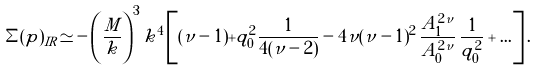<formula> <loc_0><loc_0><loc_500><loc_500>\Sigma ( p ) _ { I R } \simeq - \left ( \frac { M } { k } \right ) ^ { 3 } k ^ { 4 } \left [ ( \nu - 1 ) + q _ { 0 } ^ { 2 } \frac { 1 } { 4 ( \nu - 2 ) } - 4 \nu ( \nu - 1 ) ^ { 2 } \, \frac { A _ { 1 } ^ { 2 \nu } } { A _ { 0 } ^ { 2 \nu } } \, \frac { 1 } { q _ { 0 } ^ { 2 } } + \dots \right ] .</formula> 